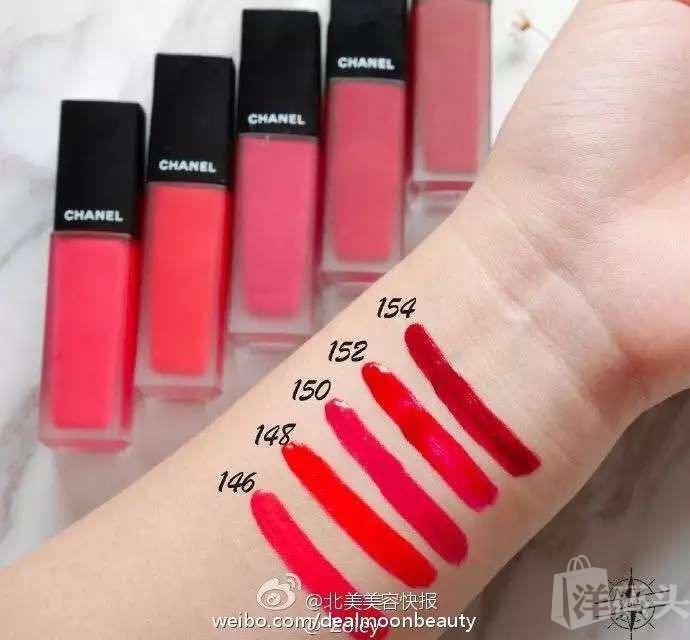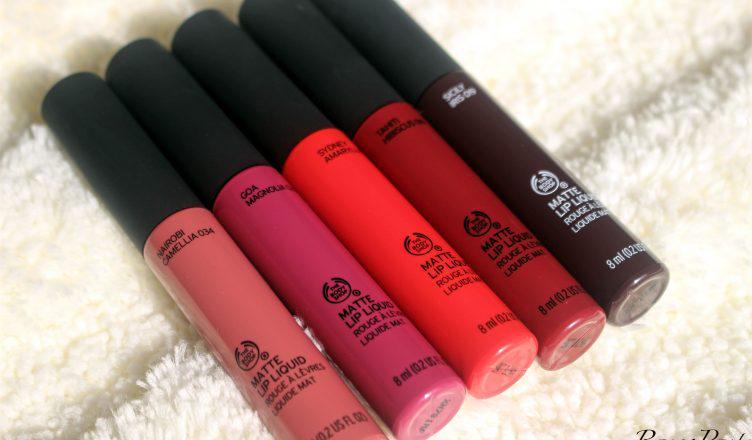The first image is the image on the left, the second image is the image on the right. For the images displayed, is the sentence "The left image shows a lipstick color test on a person's wrist area." factually correct? Answer yes or no. Yes. 